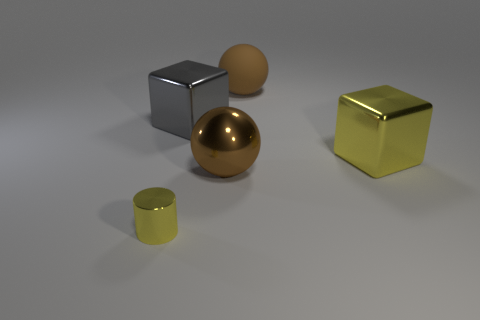Is there anything else that is the same size as the cylinder?
Provide a short and direct response. No. There is another large object that is the same shape as the big matte thing; what material is it?
Your answer should be compact. Metal. How many yellow shiny blocks have the same size as the yellow metal cylinder?
Ensure brevity in your answer.  0. What number of big brown shiny objects are there?
Your answer should be very brief. 1. Is the gray thing made of the same material as the yellow thing behind the small yellow thing?
Keep it short and to the point. Yes. How many purple things are either big metal cubes or shiny cylinders?
Provide a short and direct response. 0. There is a gray thing that is the same material as the yellow cylinder; what size is it?
Offer a terse response. Large. How many other large rubber things are the same shape as the large gray thing?
Keep it short and to the point. 0. Is the number of big matte balls that are to the left of the yellow metallic cylinder greater than the number of big yellow metallic cubes in front of the brown rubber sphere?
Provide a short and direct response. No. There is a large shiny ball; does it have the same color as the large thing that is behind the gray thing?
Your answer should be compact. Yes. 